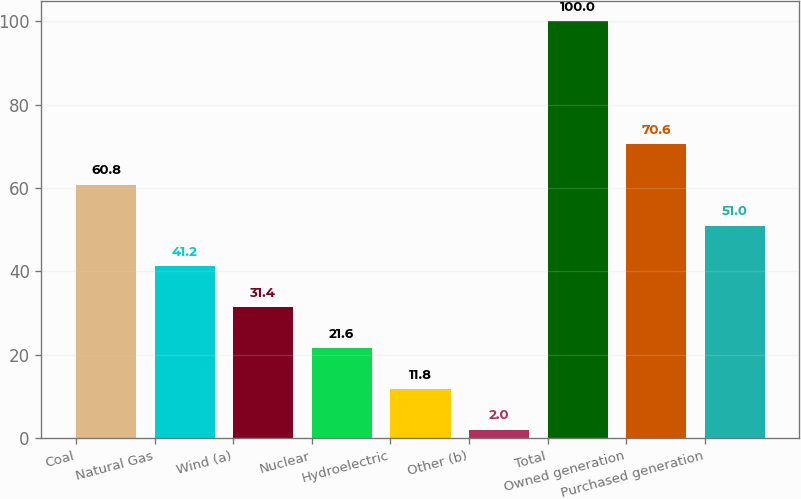Convert chart. <chart><loc_0><loc_0><loc_500><loc_500><bar_chart><fcel>Coal<fcel>Natural Gas<fcel>Wind (a)<fcel>Nuclear<fcel>Hydroelectric<fcel>Other (b)<fcel>Total<fcel>Owned generation<fcel>Purchased generation<nl><fcel>60.8<fcel>41.2<fcel>31.4<fcel>21.6<fcel>11.8<fcel>2<fcel>100<fcel>70.6<fcel>51<nl></chart> 